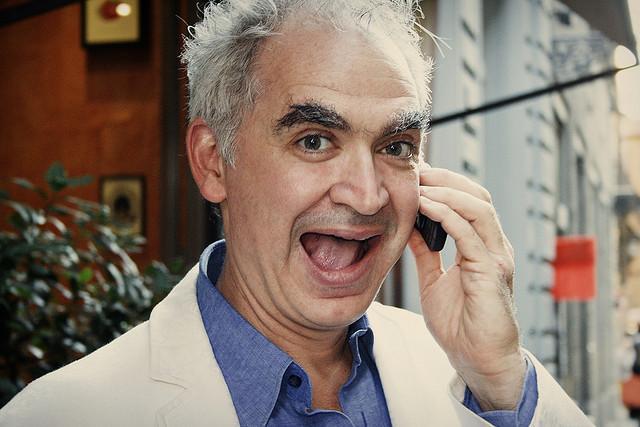How many people are aware that they are being photographed in this image?
Give a very brief answer. 1. 